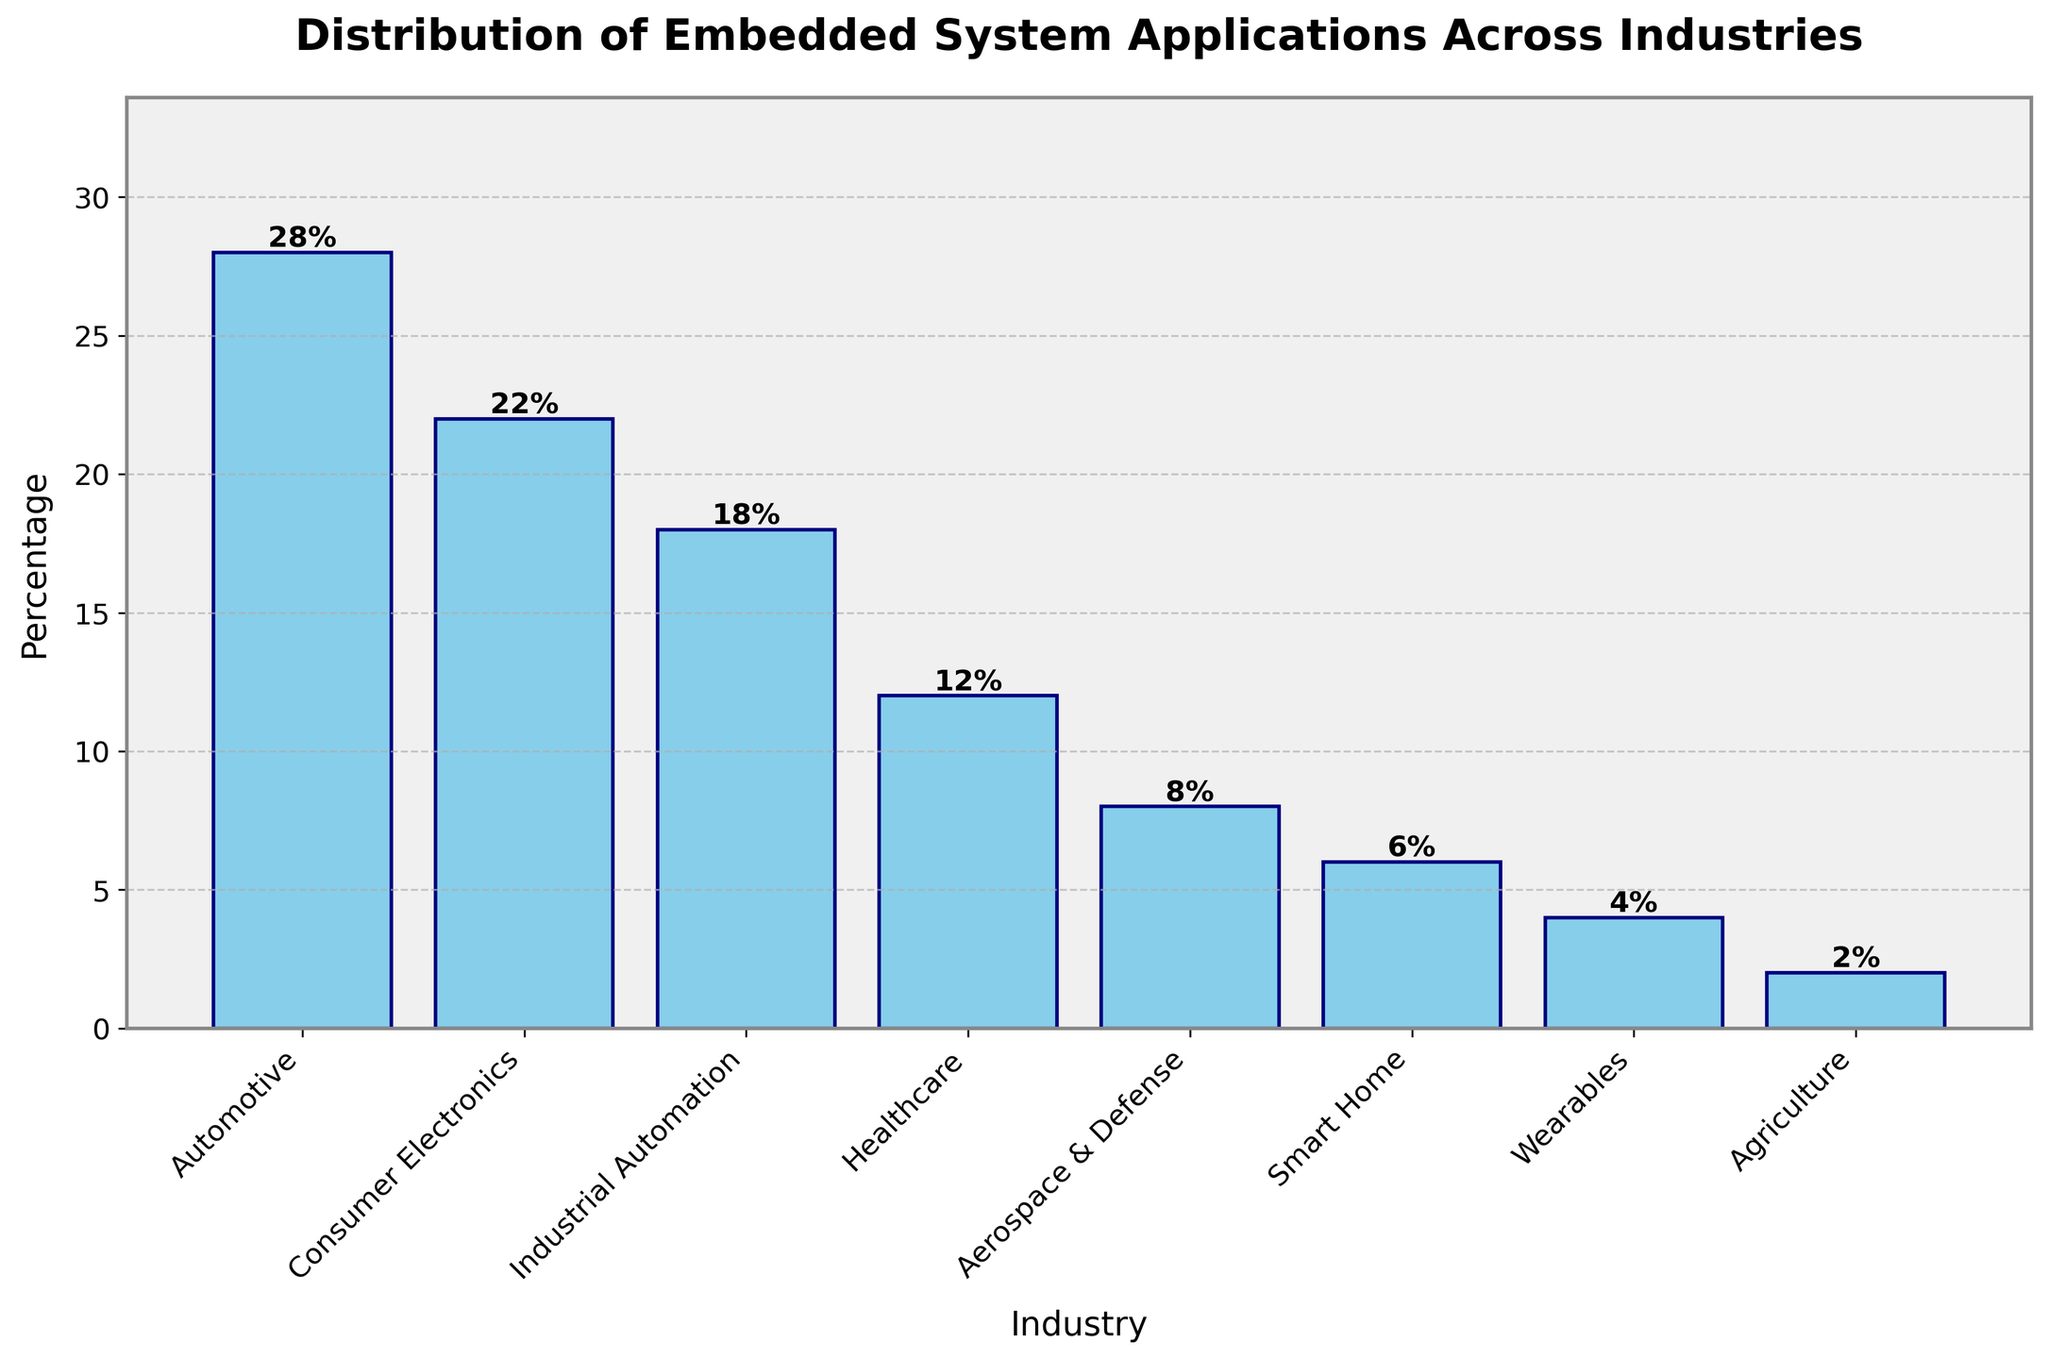What's the most common industry for embedded system applications? The bar chart shows the "Automotive" industry with the highest bar, indicating it has the highest percentage of embedded system applications at 28%.
Answer: Automotive Which industry has the smallest percentage of embedded system applications? The smallest bar on the chart represents "Agriculture," with a percentage of 2%.
Answer: Agriculture What is the combined percentage of embedded system applications in the "Consumer Electronics" and "Industrial Automation" industries? According to the chart, "Consumer Electronics" represents 22% and "Industrial Automation" represents 18%. Summing these gives 22% + 18% = 40%.
Answer: 40% Is the percentage of embedded system applications in "Healthcare" higher or lower than in "Aerospace & Defense"? The height of the bar for "Healthcare" is 12%, which is higher than the bar for "Aerospace & Defense" at 8%.
Answer: Higher How much higher is the percentage of "Automotive" compared to "Smart Home"? The "Automotive" industry is at 28%, and "Smart Home" is at 6%. The difference is 28% - 6% = 22%.
Answer: 22% What are the total percentage contributions of industries with less than 10% embedded system applications? The industries with less than 10% are "Aerospace & Defense" (8%), "Smart Home" (6%), "Wearables" (4%), and "Agriculture" (2%). Adding them together gives 8% + 6% + 4% + 2% = 20%.
Answer: 20% Rank the top three industries based on their embedded system application percentages. The top three industries based on the heights of the bars are: 1. Automotive (28%), 2. Consumer Electronics (22%), 3. Industrial Automation (18%).
Answer: Automotive, Consumer Electronics, Industrial Automation Which industries have their application percentages within the range of 5% to 15%? The bars that fall within this range are "Healthcare" (12%) and "Smart Home" (6%).
Answer: Healthcare, Smart Home Are there more embedded system applications in "Wearables" or "Agriculture"? The bar for "Wearables" is taller at 4% compared to the bar for "Agriculture" at 2%.
Answer: Wearables By how much does the percentage of "Industrial Automation" exceed that of "Wearables"? The percentage of "Industrial Automation" is 18%, while "Wearables" is 4%. The difference is 18% - 4% = 14%.
Answer: 14% 